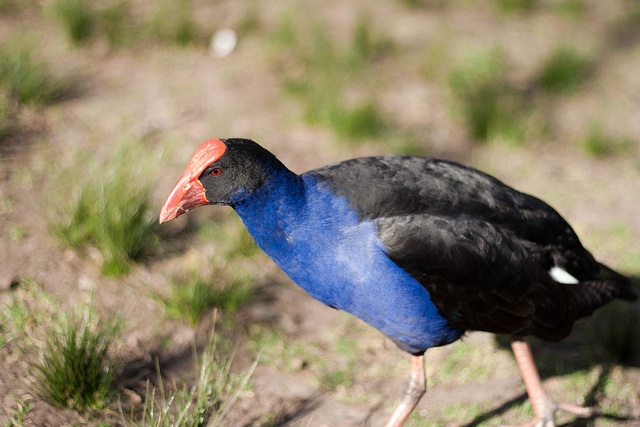Describe the objects in this image and their specific colors. I can see a bird in olive, black, gray, and blue tones in this image. 